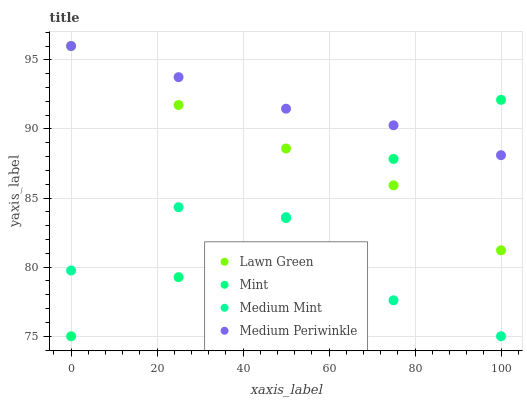Does Medium Mint have the minimum area under the curve?
Answer yes or no. Yes. Does Medium Periwinkle have the maximum area under the curve?
Answer yes or no. Yes. Does Lawn Green have the minimum area under the curve?
Answer yes or no. No. Does Lawn Green have the maximum area under the curve?
Answer yes or no. No. Is Mint the smoothest?
Answer yes or no. Yes. Is Medium Mint the roughest?
Answer yes or no. Yes. Is Lawn Green the smoothest?
Answer yes or no. No. Is Lawn Green the roughest?
Answer yes or no. No. Does Medium Mint have the lowest value?
Answer yes or no. Yes. Does Lawn Green have the lowest value?
Answer yes or no. No. Does Medium Periwinkle have the highest value?
Answer yes or no. Yes. Does Mint have the highest value?
Answer yes or no. No. Is Medium Mint less than Medium Periwinkle?
Answer yes or no. Yes. Is Medium Periwinkle greater than Medium Mint?
Answer yes or no. Yes. Does Medium Mint intersect Mint?
Answer yes or no. Yes. Is Medium Mint less than Mint?
Answer yes or no. No. Is Medium Mint greater than Mint?
Answer yes or no. No. Does Medium Mint intersect Medium Periwinkle?
Answer yes or no. No. 